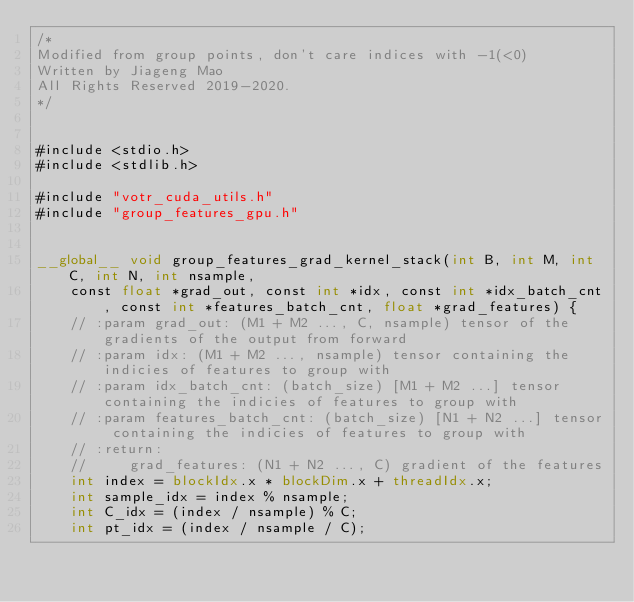<code> <loc_0><loc_0><loc_500><loc_500><_Cuda_>/*
Modified from group points, don't care indices with -1(<0)
Written by Jiageng Mao
All Rights Reserved 2019-2020.
*/


#include <stdio.h>
#include <stdlib.h>

#include "votr_cuda_utils.h"
#include "group_features_gpu.h"


__global__ void group_features_grad_kernel_stack(int B, int M, int C, int N, int nsample,
    const float *grad_out, const int *idx, const int *idx_batch_cnt, const int *features_batch_cnt, float *grad_features) {
    // :param grad_out: (M1 + M2 ..., C, nsample) tensor of the gradients of the output from forward
    // :param idx: (M1 + M2 ..., nsample) tensor containing the indicies of features to group with
    // :param idx_batch_cnt: (batch_size) [M1 + M2 ...] tensor containing the indicies of features to group with
    // :param features_batch_cnt: (batch_size) [N1 + N2 ...] tensor containing the indicies of features to group with
    // :return:
    //     grad_features: (N1 + N2 ..., C) gradient of the features
    int index = blockIdx.x * blockDim.x + threadIdx.x;
    int sample_idx = index % nsample;
    int C_idx = (index / nsample) % C;
    int pt_idx = (index / nsample / C);
</code> 